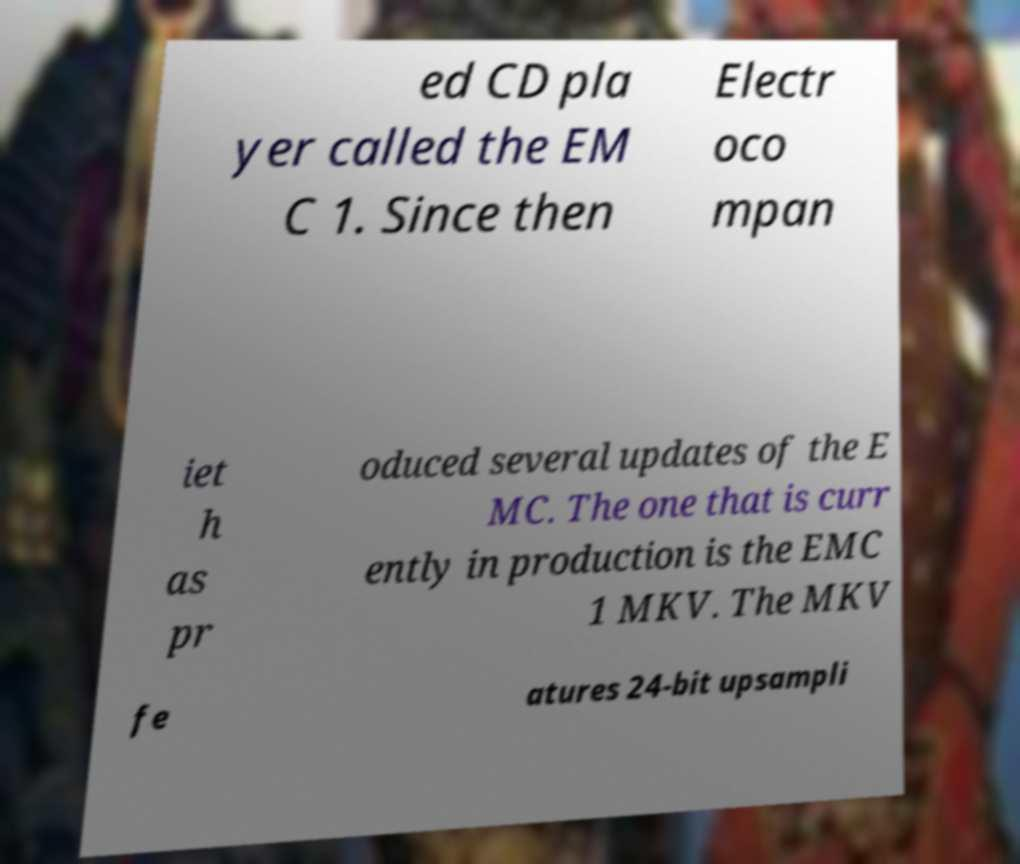Could you assist in decoding the text presented in this image and type it out clearly? ed CD pla yer called the EM C 1. Since then Electr oco mpan iet h as pr oduced several updates of the E MC. The one that is curr ently in production is the EMC 1 MKV. The MKV fe atures 24-bit upsampli 